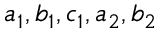Convert formula to latex. <formula><loc_0><loc_0><loc_500><loc_500>a _ { 1 } , b _ { 1 } , c _ { 1 } , a _ { 2 } , b _ { 2 }</formula> 